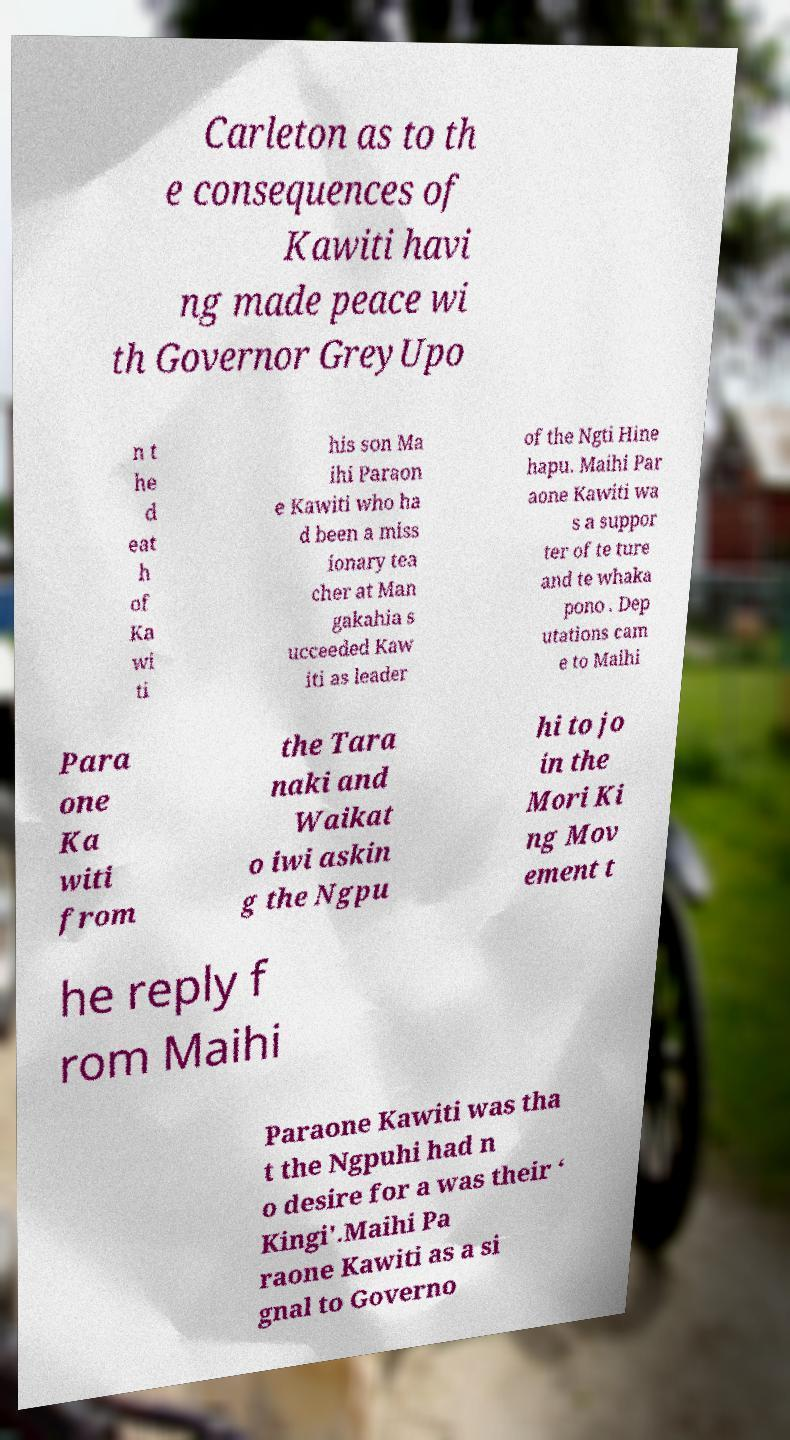Please identify and transcribe the text found in this image. Carleton as to th e consequences of Kawiti havi ng made peace wi th Governor GreyUpo n t he d eat h of Ka wi ti his son Ma ihi Paraon e Kawiti who ha d been a miss ionary tea cher at Man gakahia s ucceeded Kaw iti as leader of the Ngti Hine hapu. Maihi Par aone Kawiti wa s a suppor ter of te ture and te whaka pono . Dep utations cam e to Maihi Para one Ka witi from the Tara naki and Waikat o iwi askin g the Ngpu hi to jo in the Mori Ki ng Mov ement t he reply f rom Maihi Paraone Kawiti was tha t the Ngpuhi had n o desire for a was their ‘ Kingi'.Maihi Pa raone Kawiti as a si gnal to Governo 